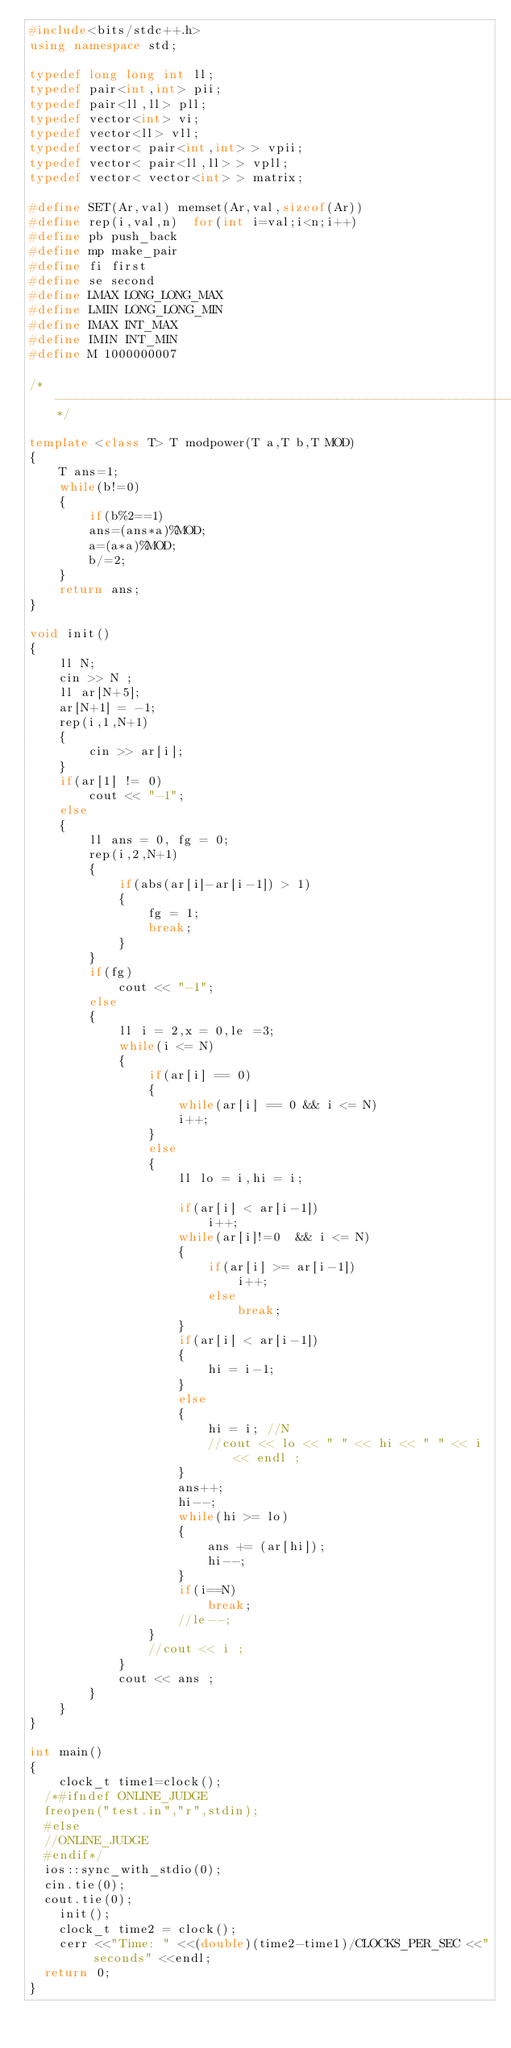<code> <loc_0><loc_0><loc_500><loc_500><_C++_>#include<bits/stdc++.h>
using namespace std;

typedef long long int ll;
typedef pair<int,int> pii;
typedef pair<ll,ll> pll;
typedef vector<int> vi;
typedef vector<ll> vll;
typedef vector< pair<int,int> > vpii;
typedef vector< pair<ll,ll> > vpll;
typedef vector< vector<int> > matrix;

#define SET(Ar,val) memset(Ar,val,sizeof(Ar))
#define rep(i,val,n)  for(int i=val;i<n;i++)
#define pb push_back
#define mp make_pair
#define fi first
#define se second
#define LMAX LONG_LONG_MAX
#define LMIN LONG_LONG_MIN
#define IMAX INT_MAX
#define IMIN INT_MIN
#define M 1000000007

/*--------------------------------------------------------------------------------------------------------------------------------*/

template <class T> T modpower(T a,T b,T MOD)
{
    T ans=1;
    while(b!=0)
    {
        if(b%2==1)
        ans=(ans*a)%MOD;
        a=(a*a)%MOD;
        b/=2;
    }
    return ans;
}

void init()
{
    ll N;
    cin >> N ;
    ll ar[N+5];
    ar[N+1] = -1;
    rep(i,1,N+1)
    {
        cin >> ar[i];
    }
    if(ar[1] != 0)
        cout << "-1";
    else
    {
        ll ans = 0, fg = 0;
        rep(i,2,N+1)
        {
            if(abs(ar[i]-ar[i-1]) > 1)
            {
                fg = 1;
                break;
            }
        }
        if(fg)
            cout << "-1";
        else
        {
            ll i = 2,x = 0,le =3;
            while(i <= N)
            {
                if(ar[i] == 0)
                {
                    while(ar[i] == 0 && i <= N)
                    i++;
                }
                else
                {
                    ll lo = i,hi = i;

                    if(ar[i] < ar[i-1])
                        i++;
                    while(ar[i]!=0  && i <= N)
                    {
                        if(ar[i] >= ar[i-1])
                            i++;
                        else
                            break;
                    }
                    if(ar[i] < ar[i-1])
                    {
                        hi = i-1;
                    }
                    else
                    {
                        hi = i; //N
                        //cout << lo << " " << hi << " " << i << endl ;
                    }
                    ans++;
                    hi--;
                    while(hi >= lo)
                    {
                        ans += (ar[hi]);
                        hi--;
                    }
                    if(i==N)
                        break;
                    //le--;
                }
                //cout << i ;
            }
            cout << ans ;
        }
    }
}

int main()
{
    clock_t time1=clock();
	/*#ifndef ONLINE_JUDGE
	freopen("test.in","r",stdin);
	#else
	//ONLINE_JUDGE
	#endif*/
	ios::sync_with_stdio(0);
	cin.tie(0);
	cout.tie(0);
    init();
    clock_t time2 = clock();
    cerr <<"Time: " <<(double)(time2-time1)/CLOCKS_PER_SEC <<" seconds" <<endl;
	return 0;
}
</code> 